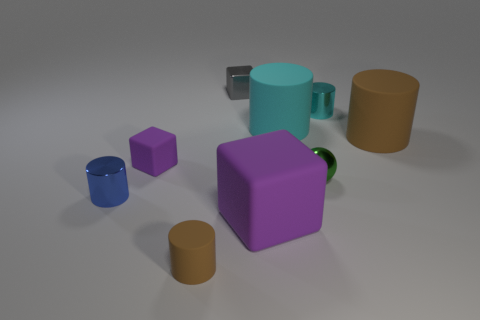What is the material of the big cyan cylinder?
Your answer should be compact. Rubber. How many other things are there of the same size as the gray metallic cube?
Offer a very short reply. 5. There is a metallic cylinder that is in front of the tiny cyan cylinder; what is its size?
Your answer should be compact. Small. What material is the tiny purple object that is on the left side of the large rubber object behind the large cylinder on the right side of the tiny cyan cylinder?
Provide a short and direct response. Rubber. Is the tiny cyan object the same shape as the small gray object?
Your response must be concise. No. What number of rubber objects are tiny cyan objects or tiny cylinders?
Give a very brief answer. 1. How many tiny yellow spheres are there?
Give a very brief answer. 0. What is the color of the metal cube that is the same size as the blue shiny thing?
Ensure brevity in your answer.  Gray. Does the blue thing have the same size as the metallic sphere?
Offer a very short reply. Yes. There is a object that is the same color as the small matte cylinder; what is its shape?
Offer a terse response. Cylinder. 